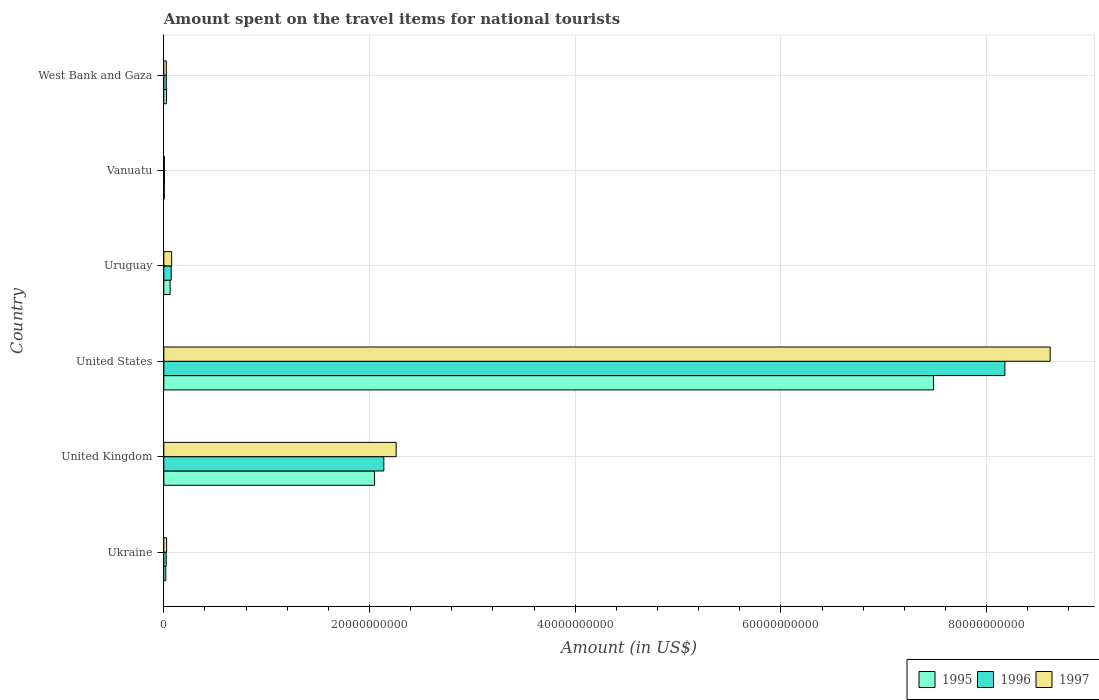How many groups of bars are there?
Your answer should be compact. 6. Are the number of bars per tick equal to the number of legend labels?
Your response must be concise. Yes. Are the number of bars on each tick of the Y-axis equal?
Make the answer very short. Yes. What is the label of the 6th group of bars from the top?
Offer a terse response. Ukraine. In how many cases, is the number of bars for a given country not equal to the number of legend labels?
Provide a short and direct response. 0. What is the amount spent on the travel items for national tourists in 1996 in Ukraine?
Your response must be concise. 2.30e+08. Across all countries, what is the maximum amount spent on the travel items for national tourists in 1996?
Make the answer very short. 8.18e+1. Across all countries, what is the minimum amount spent on the travel items for national tourists in 1996?
Provide a succinct answer. 5.60e+07. In which country was the amount spent on the travel items for national tourists in 1997 maximum?
Make the answer very short. United States. In which country was the amount spent on the travel items for national tourists in 1995 minimum?
Ensure brevity in your answer.  Vanuatu. What is the total amount spent on the travel items for national tourists in 1995 in the graph?
Offer a very short reply. 9.64e+1. What is the difference between the amount spent on the travel items for national tourists in 1997 in United States and that in Vanuatu?
Ensure brevity in your answer.  8.61e+1. What is the difference between the amount spent on the travel items for national tourists in 1996 in Ukraine and the amount spent on the travel items for national tourists in 1997 in Uruguay?
Your answer should be compact. -5.29e+08. What is the average amount spent on the travel items for national tourists in 1997 per country?
Your answer should be very brief. 1.83e+1. What is the difference between the amount spent on the travel items for national tourists in 1997 and amount spent on the travel items for national tourists in 1995 in Uruguay?
Provide a short and direct response. 1.48e+08. In how many countries, is the amount spent on the travel items for national tourists in 1997 greater than 76000000000 US$?
Ensure brevity in your answer.  1. What is the ratio of the amount spent on the travel items for national tourists in 1996 in Uruguay to that in Vanuatu?
Your response must be concise. 12.8. Is the amount spent on the travel items for national tourists in 1995 in Vanuatu less than that in West Bank and Gaza?
Provide a succinct answer. Yes. What is the difference between the highest and the second highest amount spent on the travel items for national tourists in 1996?
Offer a terse response. 6.04e+1. What is the difference between the highest and the lowest amount spent on the travel items for national tourists in 1996?
Offer a terse response. 8.17e+1. In how many countries, is the amount spent on the travel items for national tourists in 1996 greater than the average amount spent on the travel items for national tourists in 1996 taken over all countries?
Keep it short and to the point. 2. Is it the case that in every country, the sum of the amount spent on the travel items for national tourists in 1996 and amount spent on the travel items for national tourists in 1997 is greater than the amount spent on the travel items for national tourists in 1995?
Keep it short and to the point. Yes. How many bars are there?
Provide a short and direct response. 18. Are all the bars in the graph horizontal?
Make the answer very short. Yes. How many countries are there in the graph?
Offer a very short reply. 6. Where does the legend appear in the graph?
Keep it short and to the point. Bottom right. How many legend labels are there?
Your answer should be very brief. 3. What is the title of the graph?
Offer a very short reply. Amount spent on the travel items for national tourists. Does "1982" appear as one of the legend labels in the graph?
Offer a terse response. No. What is the Amount (in US$) of 1995 in Ukraine?
Your answer should be compact. 1.91e+08. What is the Amount (in US$) in 1996 in Ukraine?
Make the answer very short. 2.30e+08. What is the Amount (in US$) in 1997 in Ukraine?
Give a very brief answer. 2.70e+08. What is the Amount (in US$) in 1995 in United Kingdom?
Your answer should be compact. 2.05e+1. What is the Amount (in US$) in 1996 in United Kingdom?
Offer a terse response. 2.14e+1. What is the Amount (in US$) of 1997 in United Kingdom?
Offer a terse response. 2.26e+1. What is the Amount (in US$) of 1995 in United States?
Offer a terse response. 7.48e+1. What is the Amount (in US$) in 1996 in United States?
Give a very brief answer. 8.18e+1. What is the Amount (in US$) of 1997 in United States?
Provide a succinct answer. 8.62e+1. What is the Amount (in US$) of 1995 in Uruguay?
Your answer should be compact. 6.11e+08. What is the Amount (in US$) in 1996 in Uruguay?
Keep it short and to the point. 7.17e+08. What is the Amount (in US$) of 1997 in Uruguay?
Make the answer very short. 7.59e+08. What is the Amount (in US$) of 1995 in Vanuatu?
Your response must be concise. 4.50e+07. What is the Amount (in US$) of 1996 in Vanuatu?
Provide a short and direct response. 5.60e+07. What is the Amount (in US$) in 1997 in Vanuatu?
Offer a terse response. 5.30e+07. What is the Amount (in US$) of 1995 in West Bank and Gaza?
Keep it short and to the point. 2.55e+08. What is the Amount (in US$) in 1996 in West Bank and Gaza?
Your answer should be very brief. 2.42e+08. What is the Amount (in US$) of 1997 in West Bank and Gaza?
Provide a succinct answer. 2.39e+08. Across all countries, what is the maximum Amount (in US$) in 1995?
Provide a succinct answer. 7.48e+1. Across all countries, what is the maximum Amount (in US$) of 1996?
Give a very brief answer. 8.18e+1. Across all countries, what is the maximum Amount (in US$) of 1997?
Provide a succinct answer. 8.62e+1. Across all countries, what is the minimum Amount (in US$) of 1995?
Make the answer very short. 4.50e+07. Across all countries, what is the minimum Amount (in US$) in 1996?
Provide a short and direct response. 5.60e+07. Across all countries, what is the minimum Amount (in US$) in 1997?
Make the answer very short. 5.30e+07. What is the total Amount (in US$) in 1995 in the graph?
Keep it short and to the point. 9.64e+1. What is the total Amount (in US$) of 1996 in the graph?
Provide a short and direct response. 1.04e+11. What is the total Amount (in US$) in 1997 in the graph?
Your answer should be compact. 1.10e+11. What is the difference between the Amount (in US$) of 1995 in Ukraine and that in United Kingdom?
Make the answer very short. -2.03e+1. What is the difference between the Amount (in US$) in 1996 in Ukraine and that in United Kingdom?
Your response must be concise. -2.12e+1. What is the difference between the Amount (in US$) in 1997 in Ukraine and that in United Kingdom?
Provide a succinct answer. -2.23e+1. What is the difference between the Amount (in US$) in 1995 in Ukraine and that in United States?
Ensure brevity in your answer.  -7.46e+1. What is the difference between the Amount (in US$) of 1996 in Ukraine and that in United States?
Ensure brevity in your answer.  -8.15e+1. What is the difference between the Amount (in US$) of 1997 in Ukraine and that in United States?
Keep it short and to the point. -8.59e+1. What is the difference between the Amount (in US$) of 1995 in Ukraine and that in Uruguay?
Ensure brevity in your answer.  -4.20e+08. What is the difference between the Amount (in US$) of 1996 in Ukraine and that in Uruguay?
Keep it short and to the point. -4.87e+08. What is the difference between the Amount (in US$) in 1997 in Ukraine and that in Uruguay?
Provide a succinct answer. -4.89e+08. What is the difference between the Amount (in US$) in 1995 in Ukraine and that in Vanuatu?
Your answer should be compact. 1.46e+08. What is the difference between the Amount (in US$) of 1996 in Ukraine and that in Vanuatu?
Provide a short and direct response. 1.74e+08. What is the difference between the Amount (in US$) in 1997 in Ukraine and that in Vanuatu?
Make the answer very short. 2.17e+08. What is the difference between the Amount (in US$) in 1995 in Ukraine and that in West Bank and Gaza?
Offer a very short reply. -6.40e+07. What is the difference between the Amount (in US$) in 1996 in Ukraine and that in West Bank and Gaza?
Make the answer very short. -1.20e+07. What is the difference between the Amount (in US$) of 1997 in Ukraine and that in West Bank and Gaza?
Your answer should be very brief. 3.10e+07. What is the difference between the Amount (in US$) of 1995 in United Kingdom and that in United States?
Your answer should be very brief. -5.43e+1. What is the difference between the Amount (in US$) in 1996 in United Kingdom and that in United States?
Your response must be concise. -6.04e+1. What is the difference between the Amount (in US$) of 1997 in United Kingdom and that in United States?
Provide a succinct answer. -6.36e+1. What is the difference between the Amount (in US$) of 1995 in United Kingdom and that in Uruguay?
Make the answer very short. 1.99e+1. What is the difference between the Amount (in US$) in 1996 in United Kingdom and that in Uruguay?
Keep it short and to the point. 2.07e+1. What is the difference between the Amount (in US$) of 1997 in United Kingdom and that in Uruguay?
Keep it short and to the point. 2.18e+1. What is the difference between the Amount (in US$) in 1995 in United Kingdom and that in Vanuatu?
Make the answer very short. 2.04e+1. What is the difference between the Amount (in US$) of 1996 in United Kingdom and that in Vanuatu?
Offer a terse response. 2.13e+1. What is the difference between the Amount (in US$) in 1997 in United Kingdom and that in Vanuatu?
Keep it short and to the point. 2.25e+1. What is the difference between the Amount (in US$) in 1995 in United Kingdom and that in West Bank and Gaza?
Your answer should be compact. 2.02e+1. What is the difference between the Amount (in US$) of 1996 in United Kingdom and that in West Bank and Gaza?
Offer a terse response. 2.11e+1. What is the difference between the Amount (in US$) in 1997 in United Kingdom and that in West Bank and Gaza?
Ensure brevity in your answer.  2.23e+1. What is the difference between the Amount (in US$) of 1995 in United States and that in Uruguay?
Offer a very short reply. 7.42e+1. What is the difference between the Amount (in US$) of 1996 in United States and that in Uruguay?
Make the answer very short. 8.11e+1. What is the difference between the Amount (in US$) of 1997 in United States and that in Uruguay?
Your answer should be very brief. 8.54e+1. What is the difference between the Amount (in US$) in 1995 in United States and that in Vanuatu?
Keep it short and to the point. 7.48e+1. What is the difference between the Amount (in US$) of 1996 in United States and that in Vanuatu?
Your answer should be very brief. 8.17e+1. What is the difference between the Amount (in US$) in 1997 in United States and that in Vanuatu?
Give a very brief answer. 8.61e+1. What is the difference between the Amount (in US$) in 1995 in United States and that in West Bank and Gaza?
Your answer should be very brief. 7.46e+1. What is the difference between the Amount (in US$) of 1996 in United States and that in West Bank and Gaza?
Ensure brevity in your answer.  8.15e+1. What is the difference between the Amount (in US$) of 1997 in United States and that in West Bank and Gaza?
Your response must be concise. 8.59e+1. What is the difference between the Amount (in US$) in 1995 in Uruguay and that in Vanuatu?
Your response must be concise. 5.66e+08. What is the difference between the Amount (in US$) of 1996 in Uruguay and that in Vanuatu?
Offer a terse response. 6.61e+08. What is the difference between the Amount (in US$) in 1997 in Uruguay and that in Vanuatu?
Give a very brief answer. 7.06e+08. What is the difference between the Amount (in US$) in 1995 in Uruguay and that in West Bank and Gaza?
Your answer should be compact. 3.56e+08. What is the difference between the Amount (in US$) in 1996 in Uruguay and that in West Bank and Gaza?
Provide a short and direct response. 4.75e+08. What is the difference between the Amount (in US$) of 1997 in Uruguay and that in West Bank and Gaza?
Your response must be concise. 5.20e+08. What is the difference between the Amount (in US$) in 1995 in Vanuatu and that in West Bank and Gaza?
Your answer should be very brief. -2.10e+08. What is the difference between the Amount (in US$) in 1996 in Vanuatu and that in West Bank and Gaza?
Give a very brief answer. -1.86e+08. What is the difference between the Amount (in US$) in 1997 in Vanuatu and that in West Bank and Gaza?
Keep it short and to the point. -1.86e+08. What is the difference between the Amount (in US$) in 1995 in Ukraine and the Amount (in US$) in 1996 in United Kingdom?
Make the answer very short. -2.12e+1. What is the difference between the Amount (in US$) in 1995 in Ukraine and the Amount (in US$) in 1997 in United Kingdom?
Provide a succinct answer. -2.24e+1. What is the difference between the Amount (in US$) of 1996 in Ukraine and the Amount (in US$) of 1997 in United Kingdom?
Provide a succinct answer. -2.24e+1. What is the difference between the Amount (in US$) of 1995 in Ukraine and the Amount (in US$) of 1996 in United States?
Offer a very short reply. -8.16e+1. What is the difference between the Amount (in US$) in 1995 in Ukraine and the Amount (in US$) in 1997 in United States?
Keep it short and to the point. -8.60e+1. What is the difference between the Amount (in US$) of 1996 in Ukraine and the Amount (in US$) of 1997 in United States?
Your response must be concise. -8.59e+1. What is the difference between the Amount (in US$) of 1995 in Ukraine and the Amount (in US$) of 1996 in Uruguay?
Ensure brevity in your answer.  -5.26e+08. What is the difference between the Amount (in US$) in 1995 in Ukraine and the Amount (in US$) in 1997 in Uruguay?
Ensure brevity in your answer.  -5.68e+08. What is the difference between the Amount (in US$) in 1996 in Ukraine and the Amount (in US$) in 1997 in Uruguay?
Give a very brief answer. -5.29e+08. What is the difference between the Amount (in US$) in 1995 in Ukraine and the Amount (in US$) in 1996 in Vanuatu?
Your answer should be very brief. 1.35e+08. What is the difference between the Amount (in US$) in 1995 in Ukraine and the Amount (in US$) in 1997 in Vanuatu?
Keep it short and to the point. 1.38e+08. What is the difference between the Amount (in US$) of 1996 in Ukraine and the Amount (in US$) of 1997 in Vanuatu?
Provide a short and direct response. 1.77e+08. What is the difference between the Amount (in US$) in 1995 in Ukraine and the Amount (in US$) in 1996 in West Bank and Gaza?
Your answer should be compact. -5.10e+07. What is the difference between the Amount (in US$) in 1995 in Ukraine and the Amount (in US$) in 1997 in West Bank and Gaza?
Ensure brevity in your answer.  -4.80e+07. What is the difference between the Amount (in US$) in 1996 in Ukraine and the Amount (in US$) in 1997 in West Bank and Gaza?
Your response must be concise. -9.00e+06. What is the difference between the Amount (in US$) of 1995 in United Kingdom and the Amount (in US$) of 1996 in United States?
Give a very brief answer. -6.13e+1. What is the difference between the Amount (in US$) of 1995 in United Kingdom and the Amount (in US$) of 1997 in United States?
Make the answer very short. -6.57e+1. What is the difference between the Amount (in US$) in 1996 in United Kingdom and the Amount (in US$) in 1997 in United States?
Offer a terse response. -6.48e+1. What is the difference between the Amount (in US$) in 1995 in United Kingdom and the Amount (in US$) in 1996 in Uruguay?
Offer a very short reply. 1.98e+1. What is the difference between the Amount (in US$) of 1995 in United Kingdom and the Amount (in US$) of 1997 in Uruguay?
Provide a short and direct response. 1.97e+1. What is the difference between the Amount (in US$) in 1996 in United Kingdom and the Amount (in US$) in 1997 in Uruguay?
Your answer should be compact. 2.06e+1. What is the difference between the Amount (in US$) of 1995 in United Kingdom and the Amount (in US$) of 1996 in Vanuatu?
Provide a short and direct response. 2.04e+1. What is the difference between the Amount (in US$) in 1995 in United Kingdom and the Amount (in US$) in 1997 in Vanuatu?
Your answer should be compact. 2.04e+1. What is the difference between the Amount (in US$) of 1996 in United Kingdom and the Amount (in US$) of 1997 in Vanuatu?
Offer a very short reply. 2.13e+1. What is the difference between the Amount (in US$) of 1995 in United Kingdom and the Amount (in US$) of 1996 in West Bank and Gaza?
Provide a succinct answer. 2.02e+1. What is the difference between the Amount (in US$) in 1995 in United Kingdom and the Amount (in US$) in 1997 in West Bank and Gaza?
Provide a short and direct response. 2.02e+1. What is the difference between the Amount (in US$) of 1996 in United Kingdom and the Amount (in US$) of 1997 in West Bank and Gaza?
Keep it short and to the point. 2.12e+1. What is the difference between the Amount (in US$) of 1995 in United States and the Amount (in US$) of 1996 in Uruguay?
Your answer should be compact. 7.41e+1. What is the difference between the Amount (in US$) in 1995 in United States and the Amount (in US$) in 1997 in Uruguay?
Give a very brief answer. 7.41e+1. What is the difference between the Amount (in US$) in 1996 in United States and the Amount (in US$) in 1997 in Uruguay?
Provide a short and direct response. 8.10e+1. What is the difference between the Amount (in US$) of 1995 in United States and the Amount (in US$) of 1996 in Vanuatu?
Ensure brevity in your answer.  7.48e+1. What is the difference between the Amount (in US$) in 1995 in United States and the Amount (in US$) in 1997 in Vanuatu?
Provide a succinct answer. 7.48e+1. What is the difference between the Amount (in US$) in 1996 in United States and the Amount (in US$) in 1997 in Vanuatu?
Your answer should be compact. 8.17e+1. What is the difference between the Amount (in US$) of 1995 in United States and the Amount (in US$) of 1996 in West Bank and Gaza?
Offer a very short reply. 7.46e+1. What is the difference between the Amount (in US$) in 1995 in United States and the Amount (in US$) in 1997 in West Bank and Gaza?
Provide a short and direct response. 7.46e+1. What is the difference between the Amount (in US$) of 1996 in United States and the Amount (in US$) of 1997 in West Bank and Gaza?
Your answer should be compact. 8.15e+1. What is the difference between the Amount (in US$) of 1995 in Uruguay and the Amount (in US$) of 1996 in Vanuatu?
Your response must be concise. 5.55e+08. What is the difference between the Amount (in US$) of 1995 in Uruguay and the Amount (in US$) of 1997 in Vanuatu?
Offer a terse response. 5.58e+08. What is the difference between the Amount (in US$) of 1996 in Uruguay and the Amount (in US$) of 1997 in Vanuatu?
Give a very brief answer. 6.64e+08. What is the difference between the Amount (in US$) of 1995 in Uruguay and the Amount (in US$) of 1996 in West Bank and Gaza?
Provide a short and direct response. 3.69e+08. What is the difference between the Amount (in US$) in 1995 in Uruguay and the Amount (in US$) in 1997 in West Bank and Gaza?
Give a very brief answer. 3.72e+08. What is the difference between the Amount (in US$) in 1996 in Uruguay and the Amount (in US$) in 1997 in West Bank and Gaza?
Offer a terse response. 4.78e+08. What is the difference between the Amount (in US$) in 1995 in Vanuatu and the Amount (in US$) in 1996 in West Bank and Gaza?
Your answer should be very brief. -1.97e+08. What is the difference between the Amount (in US$) of 1995 in Vanuatu and the Amount (in US$) of 1997 in West Bank and Gaza?
Ensure brevity in your answer.  -1.94e+08. What is the difference between the Amount (in US$) in 1996 in Vanuatu and the Amount (in US$) in 1997 in West Bank and Gaza?
Make the answer very short. -1.83e+08. What is the average Amount (in US$) of 1995 per country?
Make the answer very short. 1.61e+1. What is the average Amount (in US$) in 1996 per country?
Provide a succinct answer. 1.74e+1. What is the average Amount (in US$) of 1997 per country?
Give a very brief answer. 1.83e+1. What is the difference between the Amount (in US$) of 1995 and Amount (in US$) of 1996 in Ukraine?
Make the answer very short. -3.90e+07. What is the difference between the Amount (in US$) of 1995 and Amount (in US$) of 1997 in Ukraine?
Provide a succinct answer. -7.90e+07. What is the difference between the Amount (in US$) of 1996 and Amount (in US$) of 1997 in Ukraine?
Your answer should be very brief. -4.00e+07. What is the difference between the Amount (in US$) in 1995 and Amount (in US$) in 1996 in United Kingdom?
Your response must be concise. -9.02e+08. What is the difference between the Amount (in US$) in 1995 and Amount (in US$) in 1997 in United Kingdom?
Give a very brief answer. -2.10e+09. What is the difference between the Amount (in US$) of 1996 and Amount (in US$) of 1997 in United Kingdom?
Provide a short and direct response. -1.20e+09. What is the difference between the Amount (in US$) of 1995 and Amount (in US$) of 1996 in United States?
Ensure brevity in your answer.  -6.94e+09. What is the difference between the Amount (in US$) of 1995 and Amount (in US$) of 1997 in United States?
Your answer should be compact. -1.13e+1. What is the difference between the Amount (in US$) of 1996 and Amount (in US$) of 1997 in United States?
Give a very brief answer. -4.40e+09. What is the difference between the Amount (in US$) in 1995 and Amount (in US$) in 1996 in Uruguay?
Your answer should be compact. -1.06e+08. What is the difference between the Amount (in US$) of 1995 and Amount (in US$) of 1997 in Uruguay?
Your answer should be very brief. -1.48e+08. What is the difference between the Amount (in US$) of 1996 and Amount (in US$) of 1997 in Uruguay?
Provide a short and direct response. -4.20e+07. What is the difference between the Amount (in US$) in 1995 and Amount (in US$) in 1996 in Vanuatu?
Your response must be concise. -1.10e+07. What is the difference between the Amount (in US$) in 1995 and Amount (in US$) in 1997 in Vanuatu?
Ensure brevity in your answer.  -8.00e+06. What is the difference between the Amount (in US$) in 1996 and Amount (in US$) in 1997 in Vanuatu?
Offer a very short reply. 3.00e+06. What is the difference between the Amount (in US$) in 1995 and Amount (in US$) in 1996 in West Bank and Gaza?
Your response must be concise. 1.30e+07. What is the difference between the Amount (in US$) of 1995 and Amount (in US$) of 1997 in West Bank and Gaza?
Offer a very short reply. 1.60e+07. What is the ratio of the Amount (in US$) of 1995 in Ukraine to that in United Kingdom?
Offer a terse response. 0.01. What is the ratio of the Amount (in US$) in 1996 in Ukraine to that in United Kingdom?
Your answer should be very brief. 0.01. What is the ratio of the Amount (in US$) in 1997 in Ukraine to that in United Kingdom?
Provide a succinct answer. 0.01. What is the ratio of the Amount (in US$) in 1995 in Ukraine to that in United States?
Provide a short and direct response. 0. What is the ratio of the Amount (in US$) of 1996 in Ukraine to that in United States?
Give a very brief answer. 0. What is the ratio of the Amount (in US$) of 1997 in Ukraine to that in United States?
Offer a terse response. 0. What is the ratio of the Amount (in US$) in 1995 in Ukraine to that in Uruguay?
Keep it short and to the point. 0.31. What is the ratio of the Amount (in US$) in 1996 in Ukraine to that in Uruguay?
Keep it short and to the point. 0.32. What is the ratio of the Amount (in US$) of 1997 in Ukraine to that in Uruguay?
Provide a succinct answer. 0.36. What is the ratio of the Amount (in US$) of 1995 in Ukraine to that in Vanuatu?
Offer a very short reply. 4.24. What is the ratio of the Amount (in US$) in 1996 in Ukraine to that in Vanuatu?
Keep it short and to the point. 4.11. What is the ratio of the Amount (in US$) in 1997 in Ukraine to that in Vanuatu?
Provide a short and direct response. 5.09. What is the ratio of the Amount (in US$) of 1995 in Ukraine to that in West Bank and Gaza?
Your answer should be compact. 0.75. What is the ratio of the Amount (in US$) of 1996 in Ukraine to that in West Bank and Gaza?
Offer a terse response. 0.95. What is the ratio of the Amount (in US$) of 1997 in Ukraine to that in West Bank and Gaza?
Your answer should be compact. 1.13. What is the ratio of the Amount (in US$) in 1995 in United Kingdom to that in United States?
Keep it short and to the point. 0.27. What is the ratio of the Amount (in US$) of 1996 in United Kingdom to that in United States?
Make the answer very short. 0.26. What is the ratio of the Amount (in US$) of 1997 in United Kingdom to that in United States?
Provide a succinct answer. 0.26. What is the ratio of the Amount (in US$) in 1995 in United Kingdom to that in Uruguay?
Offer a terse response. 33.53. What is the ratio of the Amount (in US$) of 1996 in United Kingdom to that in Uruguay?
Offer a very short reply. 29.83. What is the ratio of the Amount (in US$) of 1997 in United Kingdom to that in Uruguay?
Ensure brevity in your answer.  29.76. What is the ratio of the Amount (in US$) in 1995 in United Kingdom to that in Vanuatu?
Offer a very short reply. 455.27. What is the ratio of the Amount (in US$) of 1996 in United Kingdom to that in Vanuatu?
Provide a succinct answer. 381.95. What is the ratio of the Amount (in US$) in 1997 in United Kingdom to that in Vanuatu?
Make the answer very short. 426.15. What is the ratio of the Amount (in US$) in 1995 in United Kingdom to that in West Bank and Gaza?
Offer a very short reply. 80.34. What is the ratio of the Amount (in US$) in 1996 in United Kingdom to that in West Bank and Gaza?
Offer a very short reply. 88.38. What is the ratio of the Amount (in US$) of 1997 in United Kingdom to that in West Bank and Gaza?
Your response must be concise. 94.5. What is the ratio of the Amount (in US$) of 1995 in United States to that in Uruguay?
Your answer should be compact. 122.48. What is the ratio of the Amount (in US$) in 1996 in United States to that in Uruguay?
Give a very brief answer. 114.05. What is the ratio of the Amount (in US$) of 1997 in United States to that in Uruguay?
Make the answer very short. 113.54. What is the ratio of the Amount (in US$) in 1995 in United States to that in Vanuatu?
Offer a terse response. 1662.98. What is the ratio of the Amount (in US$) of 1996 in United States to that in Vanuatu?
Offer a very short reply. 1460.21. What is the ratio of the Amount (in US$) of 1997 in United States to that in Vanuatu?
Your answer should be compact. 1625.94. What is the ratio of the Amount (in US$) of 1995 in United States to that in West Bank and Gaza?
Give a very brief answer. 293.47. What is the ratio of the Amount (in US$) in 1996 in United States to that in West Bank and Gaza?
Provide a short and direct response. 337.9. What is the ratio of the Amount (in US$) of 1997 in United States to that in West Bank and Gaza?
Provide a short and direct response. 360.56. What is the ratio of the Amount (in US$) in 1995 in Uruguay to that in Vanuatu?
Provide a succinct answer. 13.58. What is the ratio of the Amount (in US$) of 1996 in Uruguay to that in Vanuatu?
Ensure brevity in your answer.  12.8. What is the ratio of the Amount (in US$) of 1997 in Uruguay to that in Vanuatu?
Offer a very short reply. 14.32. What is the ratio of the Amount (in US$) of 1995 in Uruguay to that in West Bank and Gaza?
Keep it short and to the point. 2.4. What is the ratio of the Amount (in US$) in 1996 in Uruguay to that in West Bank and Gaza?
Offer a very short reply. 2.96. What is the ratio of the Amount (in US$) of 1997 in Uruguay to that in West Bank and Gaza?
Give a very brief answer. 3.18. What is the ratio of the Amount (in US$) of 1995 in Vanuatu to that in West Bank and Gaza?
Make the answer very short. 0.18. What is the ratio of the Amount (in US$) in 1996 in Vanuatu to that in West Bank and Gaza?
Offer a terse response. 0.23. What is the ratio of the Amount (in US$) of 1997 in Vanuatu to that in West Bank and Gaza?
Offer a terse response. 0.22. What is the difference between the highest and the second highest Amount (in US$) of 1995?
Ensure brevity in your answer.  5.43e+1. What is the difference between the highest and the second highest Amount (in US$) of 1996?
Ensure brevity in your answer.  6.04e+1. What is the difference between the highest and the second highest Amount (in US$) in 1997?
Provide a succinct answer. 6.36e+1. What is the difference between the highest and the lowest Amount (in US$) of 1995?
Your response must be concise. 7.48e+1. What is the difference between the highest and the lowest Amount (in US$) of 1996?
Your answer should be very brief. 8.17e+1. What is the difference between the highest and the lowest Amount (in US$) in 1997?
Offer a terse response. 8.61e+1. 